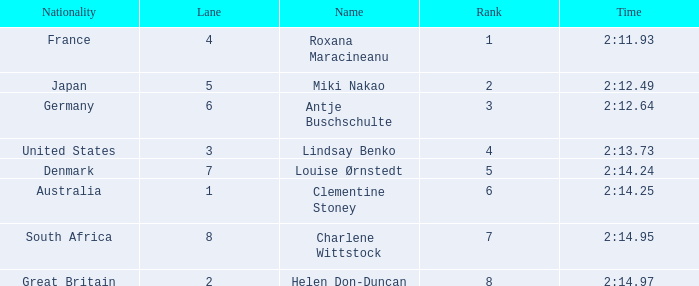Could you parse the entire table? {'header': ['Nationality', 'Lane', 'Name', 'Rank', 'Time'], 'rows': [['France', '4', 'Roxana Maracineanu', '1', '2:11.93'], ['Japan', '5', 'Miki Nakao', '2', '2:12.49'], ['Germany', '6', 'Antje Buschschulte', '3', '2:12.64'], ['United States', '3', 'Lindsay Benko', '4', '2:13.73'], ['Denmark', '7', 'Louise Ørnstedt', '5', '2:14.24'], ['Australia', '1', 'Clementine Stoney', '6', '2:14.25'], ['South Africa', '8', 'Charlene Wittstock', '7', '2:14.95'], ['Great Britain', '2', 'Helen Don-Duncan', '8', '2:14.97']]} What is the number of lane with a rank more than 2 for louise ørnstedt? 1.0. 